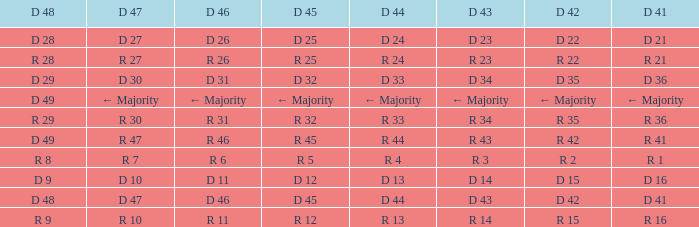Name the D 47 when it has a D 45 of d 32 D 30. 